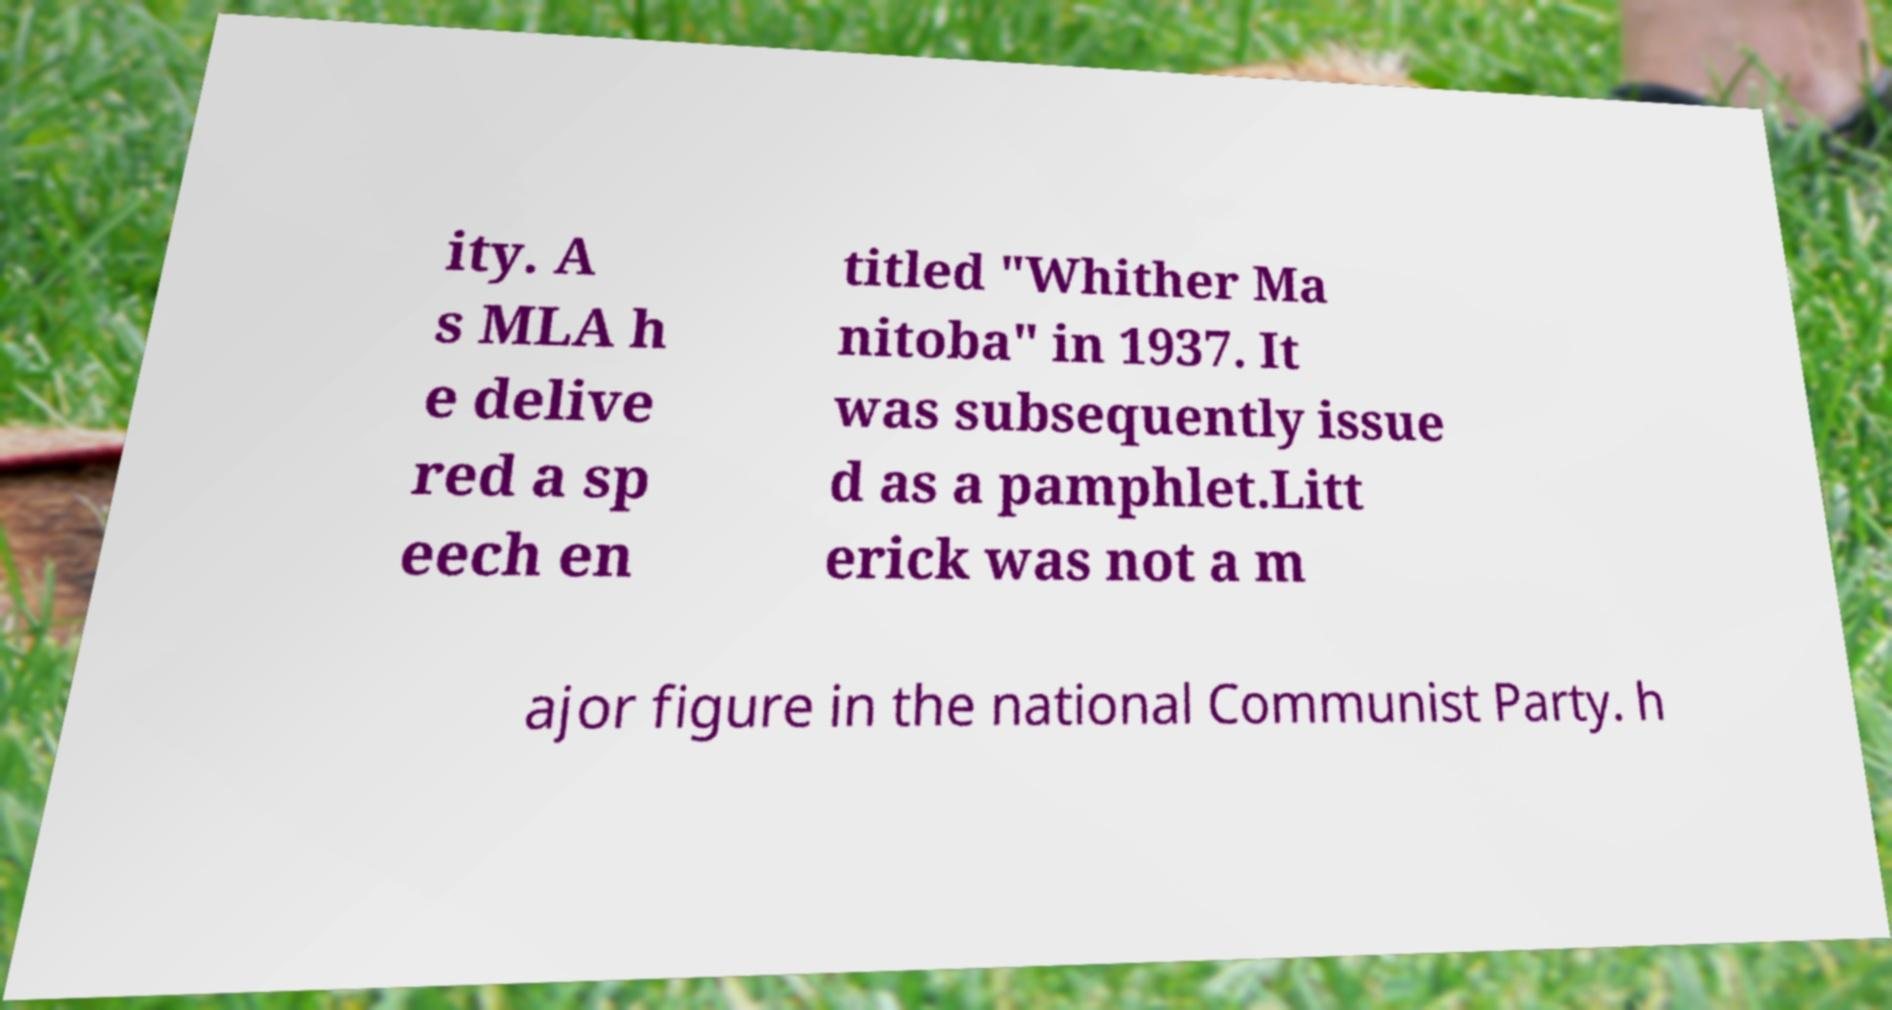Could you extract and type out the text from this image? ity. A s MLA h e delive red a sp eech en titled "Whither Ma nitoba" in 1937. It was subsequently issue d as a pamphlet.Litt erick was not a m ajor figure in the national Communist Party. h 